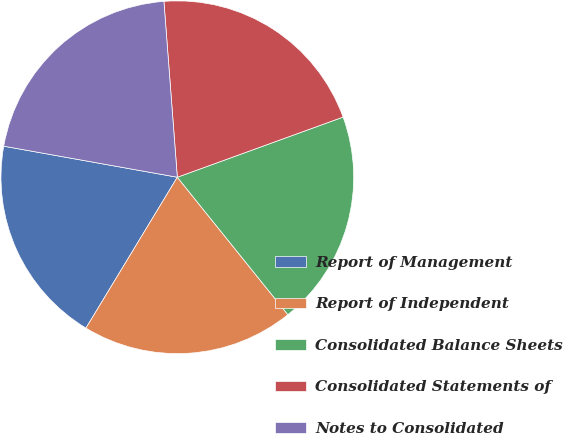Convert chart. <chart><loc_0><loc_0><loc_500><loc_500><pie_chart><fcel>Report of Management<fcel>Report of Independent<fcel>Consolidated Balance Sheets<fcel>Consolidated Statements of<fcel>Notes to Consolidated<nl><fcel>19.15%<fcel>19.45%<fcel>19.76%<fcel>20.67%<fcel>20.97%<nl></chart> 